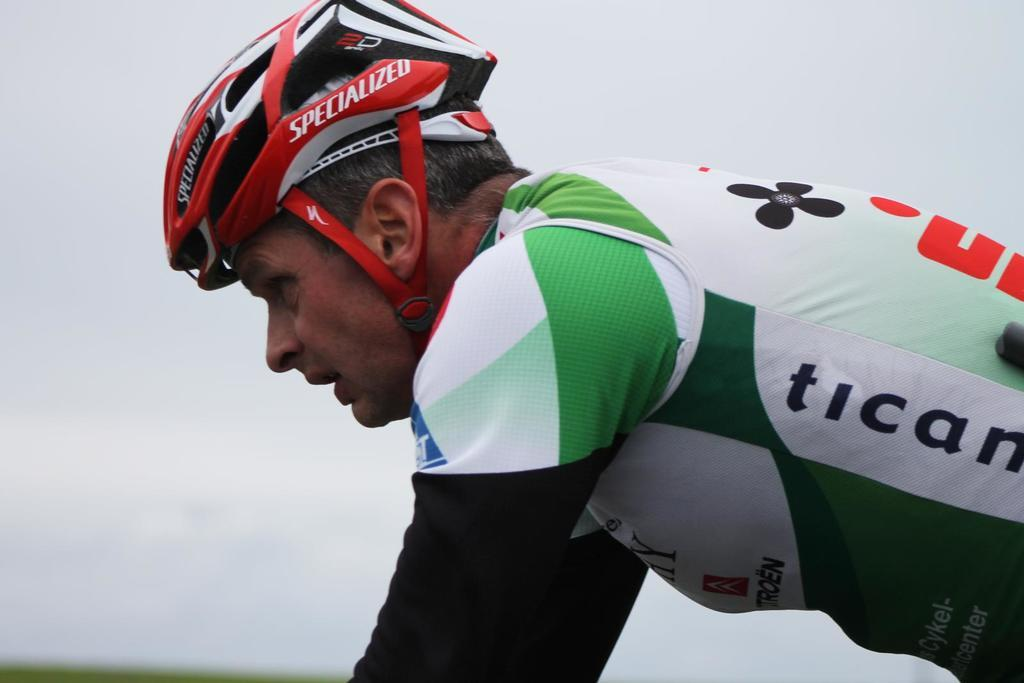What is the main subject of the image? There is a person in the image. What is the person wearing on their head? The person is wearing a helmet. What color is the background of the image? The background of the image is white. Can you see any furniture in the image? There is no furniture present in the image. Is the person in the image standing near the ocean? There is no ocean visible in the image, and the person is not standing near any body of water. 